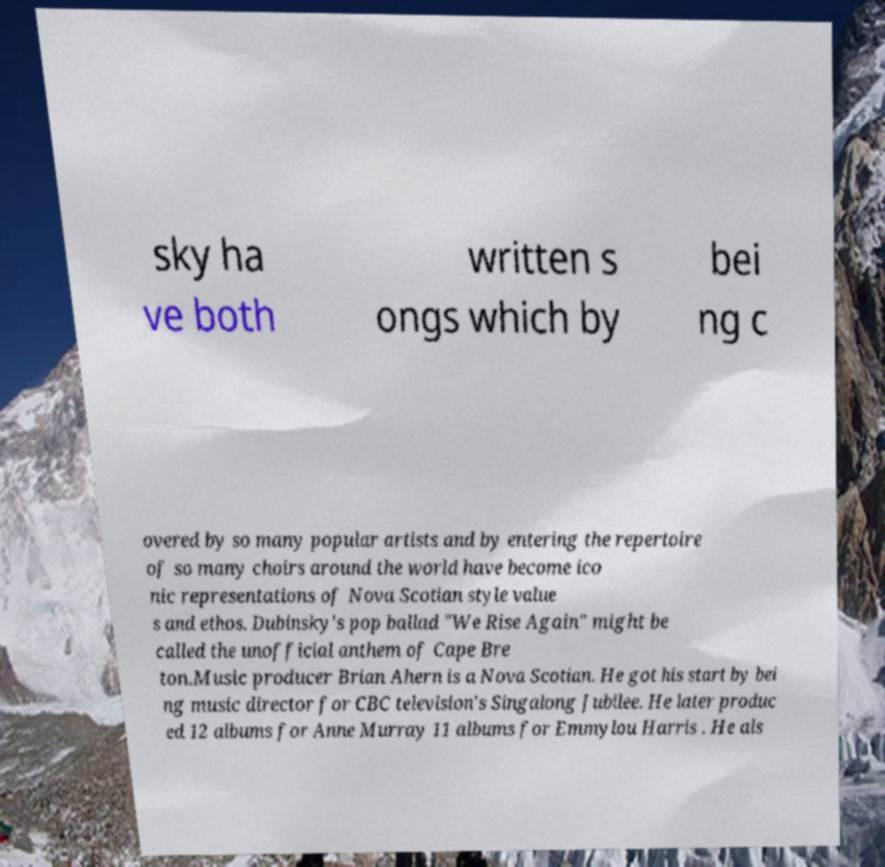Can you accurately transcribe the text from the provided image for me? sky ha ve both written s ongs which by bei ng c overed by so many popular artists and by entering the repertoire of so many choirs around the world have become ico nic representations of Nova Scotian style value s and ethos. Dubinsky's pop ballad "We Rise Again" might be called the unofficial anthem of Cape Bre ton.Music producer Brian Ahern is a Nova Scotian. He got his start by bei ng music director for CBC television's Singalong Jubilee. He later produc ed 12 albums for Anne Murray 11 albums for Emmylou Harris . He als 